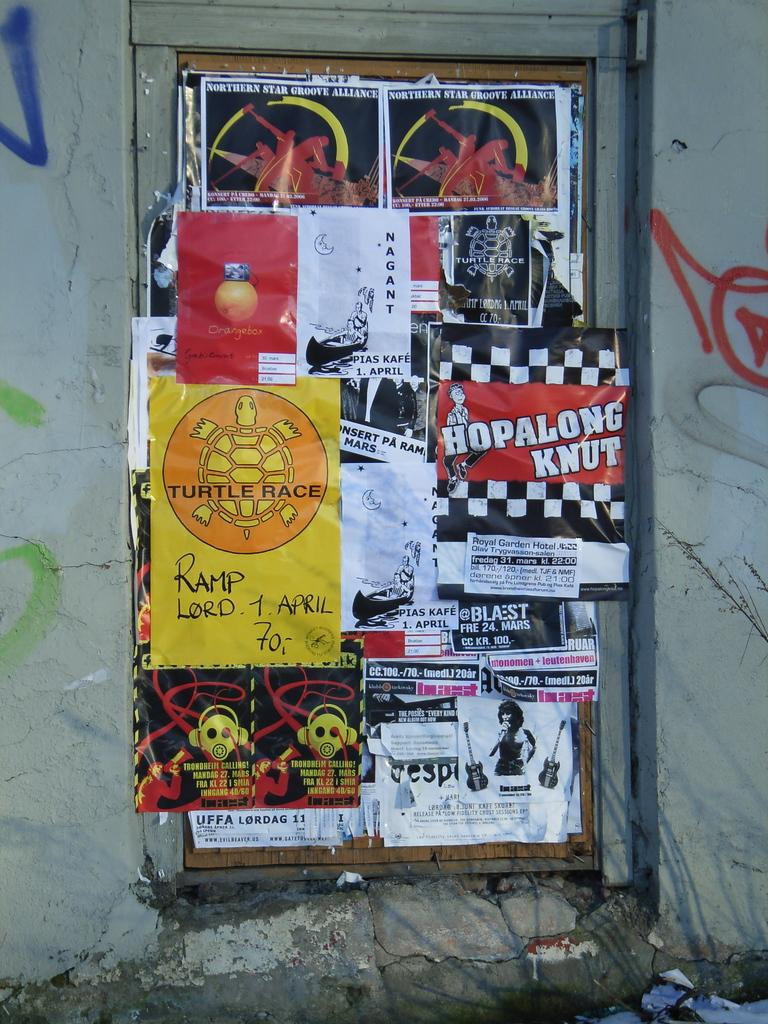<image>
Create a compact narrative representing the image presented. a yellow piece of paper that says Turtle Race on it 